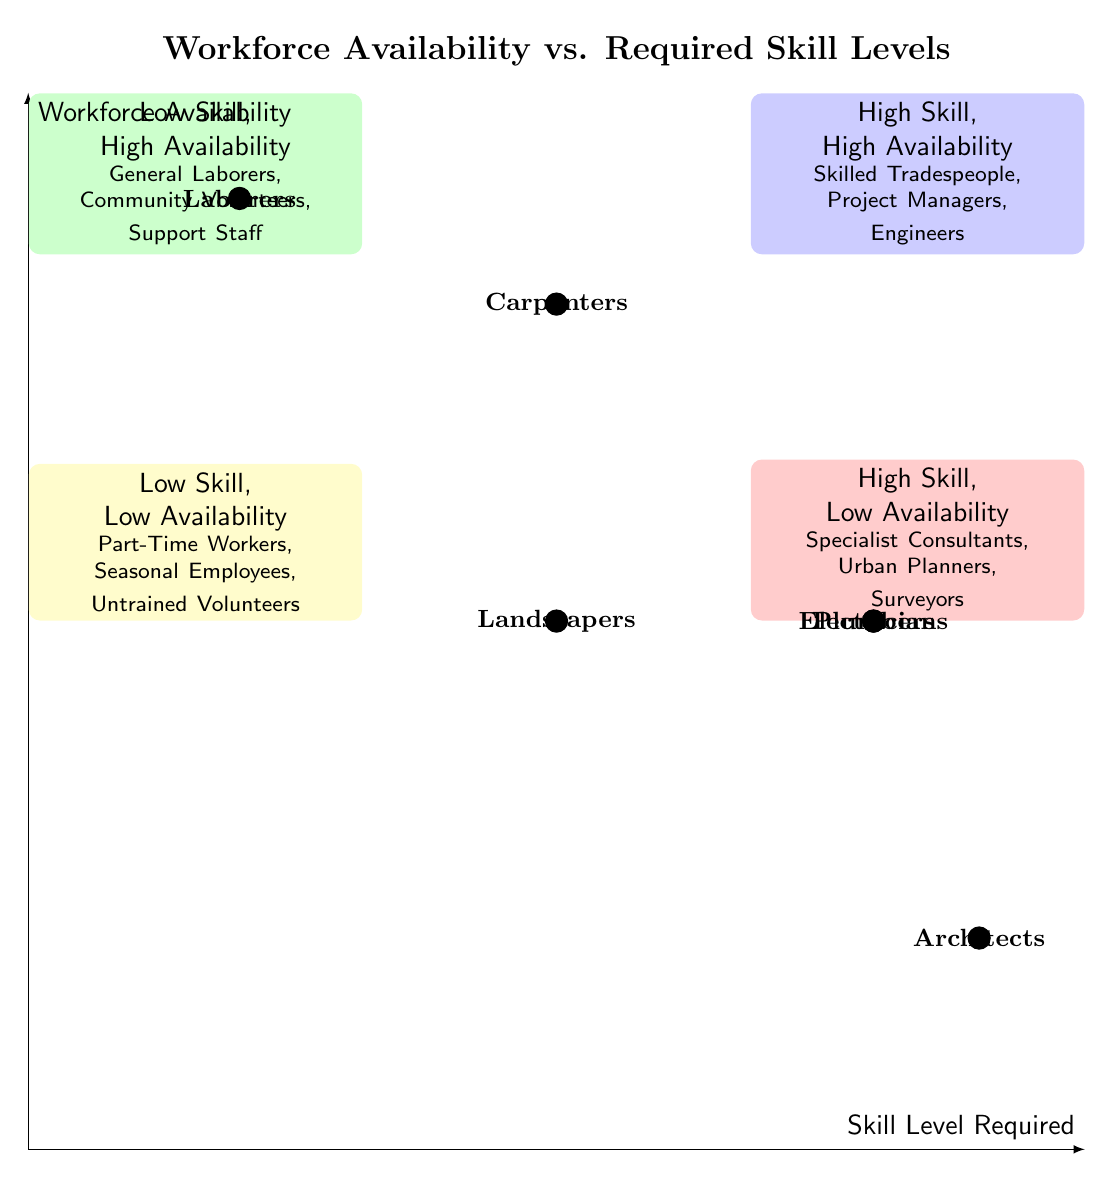What is located in the top right quadrant? The top right quadrant is labeled as "High Skill, High Availability" and contains Skilled Tradespeople, Project Managers, and Engineers.
Answer: High Skill, High Availability How many data points are in the low skill, high availability category? In the low skill, high availability (top left) category, there are three data points: General Laborers, Community Volunteers, and Support Staff.
Answer: Three Which profession has high skill and low availability? The professions that require high skill and have low availability are Specialist Consultants, Urban Planners, and Surveyors.
Answer: Specialist Consultants What is the skill level required for Carpenters? Carpenters require a medium skill level, as indicated by their placement in the corresponding location of the quadrant chart.
Answer: Medium Which two professions have the same skill level and workforce availability? Electricians and Plumbers both have high skill and medium availability, which means they are placed at the same point on the diagram.
Answer: Electricians and Plumbers What is the name of the profession with low skill and low availability? The profession indicated as having low skill and low availability is represented by Part-Time Workers, Seasonal Employees, and Untrained Volunteers.
Answer: Part-Time Workers What does the bottom left quadrant represent? The bottom left quadrant is labeled "Low Skill, Low Availability," indicating a lack of both skilled workers and available workforce.
Answer: Low Skill, Low Availability Where are Laborers positioned in terms of skill level and workforce availability? Laborers are positioned in the bottom left quadrant, indicating they require low skill and have high availability relative to the other professions.
Answer: Low Skill, High Availability 